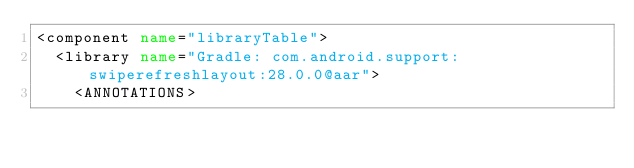<code> <loc_0><loc_0><loc_500><loc_500><_XML_><component name="libraryTable">
  <library name="Gradle: com.android.support:swiperefreshlayout:28.0.0@aar">
    <ANNOTATIONS></code> 